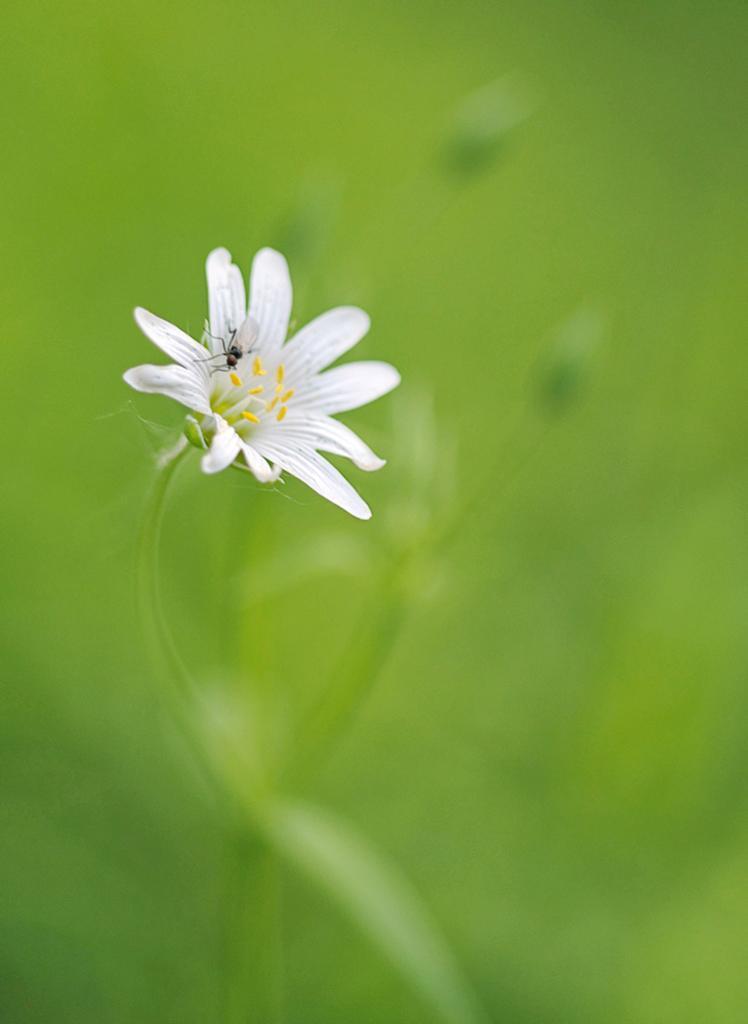How would you summarize this image in a sentence or two? In this image I can see a flower which is white and yellow in color and a insect on the flower which is black and white in color. In the background I can see a plant which is green in color. 